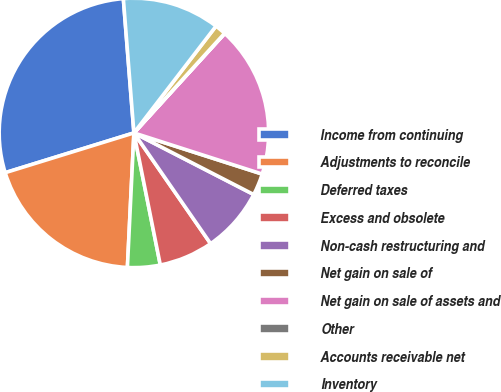<chart> <loc_0><loc_0><loc_500><loc_500><pie_chart><fcel>Income from continuing<fcel>Adjustments to reconcile<fcel>Deferred taxes<fcel>Excess and obsolete<fcel>Non-cash restructuring and<fcel>Net gain on sale of<fcel>Net gain on sale of assets and<fcel>Other<fcel>Accounts receivable net<fcel>Inventory<nl><fcel>28.52%<fcel>19.46%<fcel>3.91%<fcel>6.5%<fcel>7.8%<fcel>2.62%<fcel>18.16%<fcel>0.03%<fcel>1.32%<fcel>11.68%<nl></chart> 